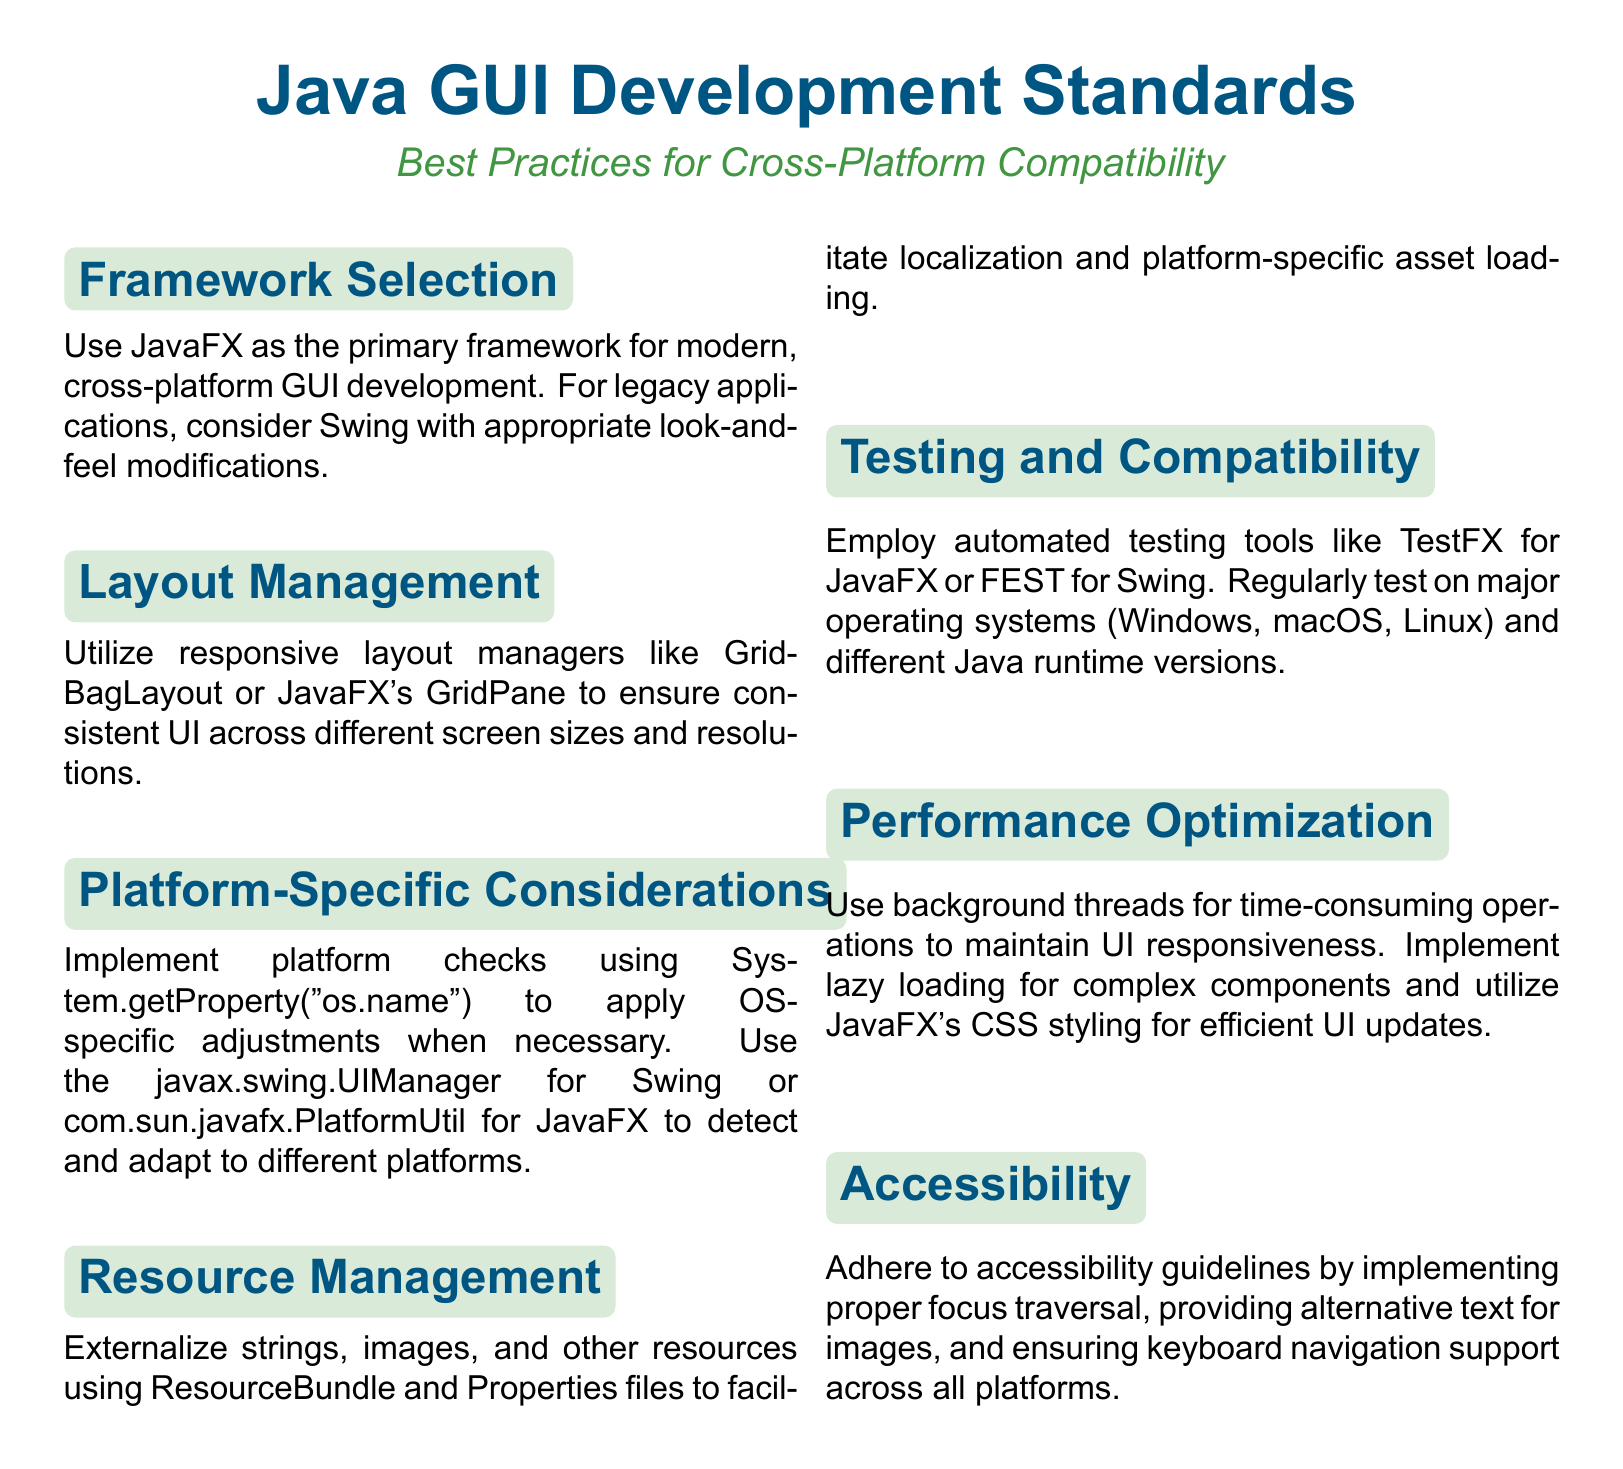What is the primary framework for modern GUI development? The document specifies that JavaFX should be used as the primary framework for modern, cross-platform GUI development.
Answer: JavaFX Which layout managers are recommended for consistent UI? The document mentions using responsive layout managers like GridBagLayout or JavaFX's GridPane for consistent UI across different screen sizes.
Answer: GridBagLayout, GridPane What should be used to detect the operating system? The document states that System.getProperty("os.name") should be used for applying OS-specific adjustments.
Answer: System.getProperty("os.name") Which automated testing tool is suggested for JavaFX? According to the document, TestFX is recommended as an automated testing tool for JavaFX applications.
Answer: TestFX What is a key consideration for accessibility? The document indicates that providing alternative text for images is a key consideration for accessibility.
Answer: Alternative text What type of threads should be used for time-consuming operations? The document advises using background threads to maintain UI responsiveness during time-consuming operations.
Answer: Background threads Which file types are suggested for resource management? The document recommends externalizing strings and images using ResourceBundle and Properties files for effective resource management.
Answer: ResourceBundle, Properties files What is the purpose of lazy loading? The document mentions that lazy loading is implemented for complex components to enhance performance.
Answer: Performance How many major operating systems should be regularly tested? The document states that regular testing should be conducted on major operating systems, specifically three mentioned: Windows, macOS, and Linux.
Answer: Three 